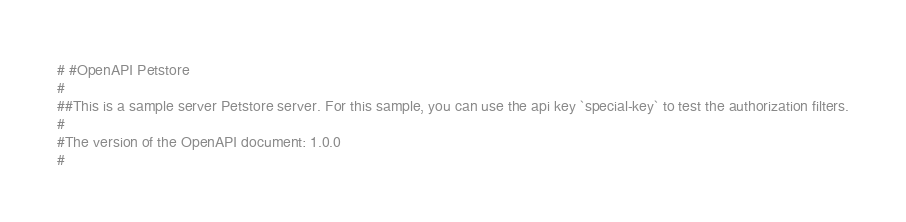Convert code to text. <code><loc_0><loc_0><loc_500><loc_500><_Crystal_># #OpenAPI Petstore
#
##This is a sample server Petstore server. For this sample, you can use the api key `special-key` to test the authorization filters.
#
#The version of the OpenAPI document: 1.0.0
#</code> 